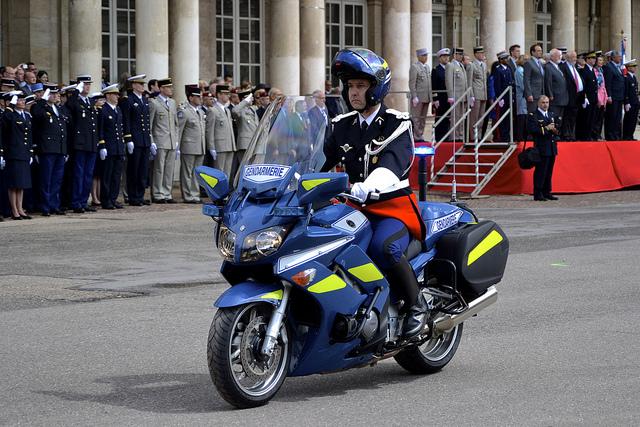What kind of service man is riding the motorcycle?
Write a very short answer. Police. Is this rider in uniform?
Keep it brief. Yes. Why are the people in uniform?
Quick response, please. Military. Are these all police officers?
Be succinct. No. What color is the motorcycle?
Answer briefly. Blue. 